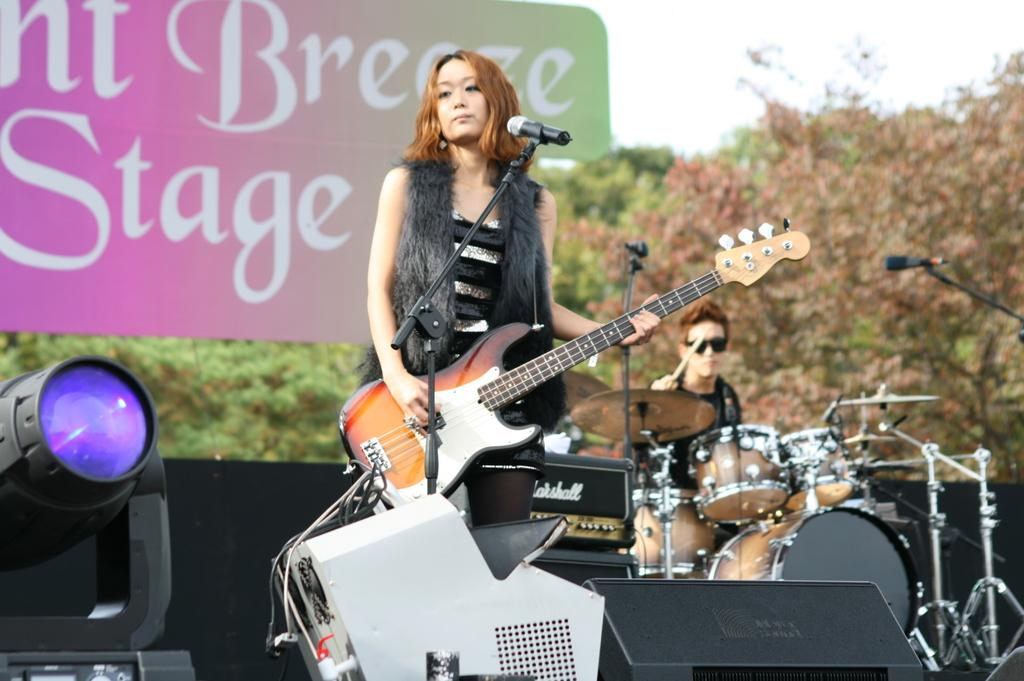What is the woman in the image holding? The woman is holding a guitar. What is the man in the image holding? The man is holding a stick. What object is present for amplifying sound in the image? There is a microphone in the image. What type of vegetation can be seen in the background of the image? There are trees in the background of the image. Can you tell me how many mountains are visible in the image? There are no mountains visible in the image; only trees can be seen in the background. What type of father is present in the image? There is no father mentioned or depicted in the image. 